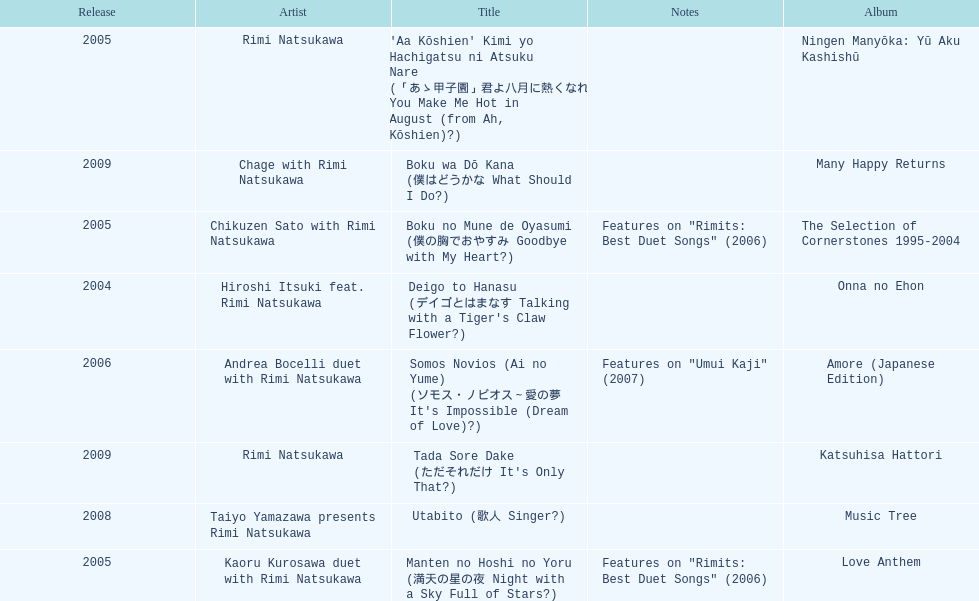How many other appearance did this artist make in 2005? 3. 